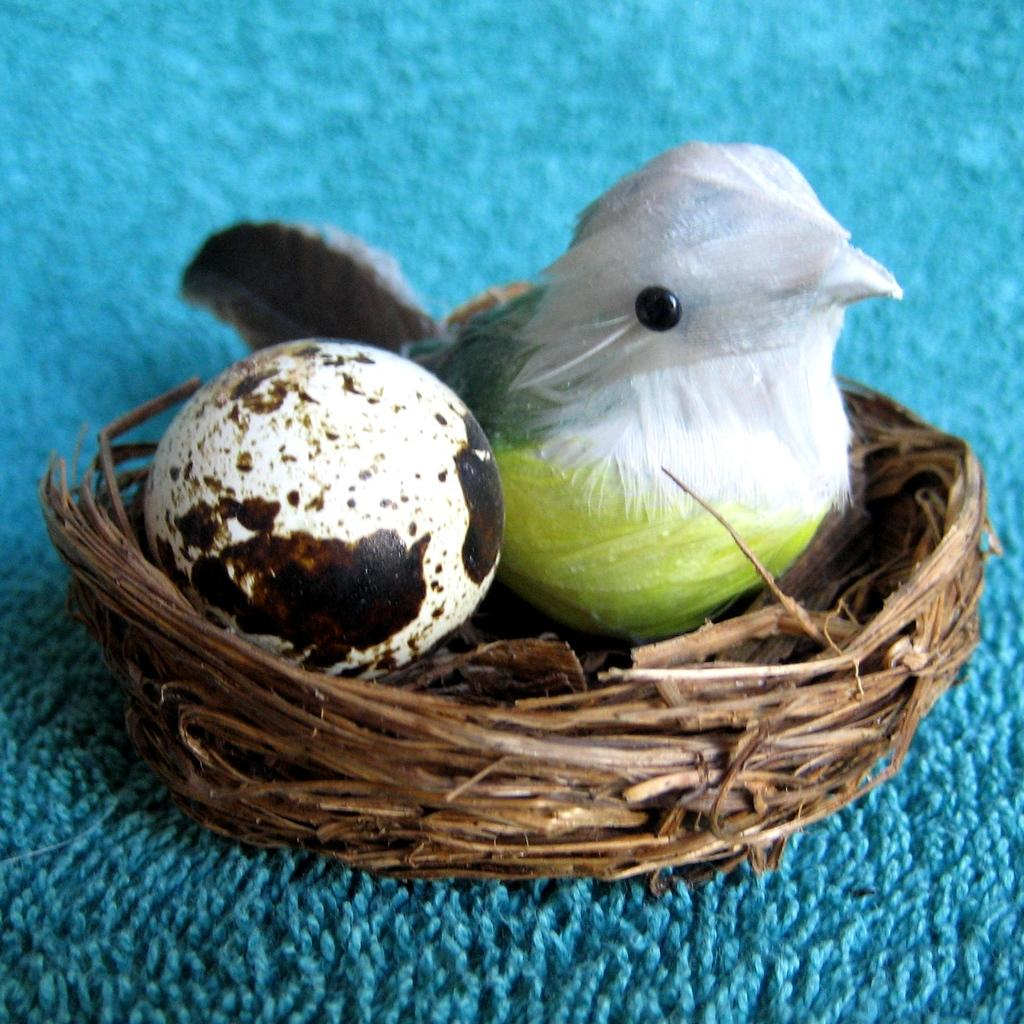What type of animal is represented by the object in the image? There is an artificial bird in the image. What is located near the artificial bird? There is an egg in the image. Where is the egg placed? The egg is in a nest. How is the nest positioned? The nest is in a cloth. What color is the cloth? The cloth is blue in color. How does the curtain affect the lighting in the image? There is no curtain present in the image, so its effect on the lighting cannot be determined. 